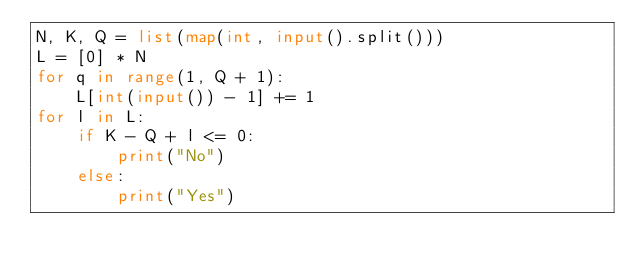<code> <loc_0><loc_0><loc_500><loc_500><_Python_>N, K, Q = list(map(int, input().split()))
L = [0] * N
for q in range(1, Q + 1):
    L[int(input()) - 1] += 1
for l in L:
    if K - Q + l <= 0:
        print("No")
    else:
        print("Yes")
</code> 